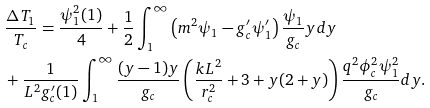Convert formula to latex. <formula><loc_0><loc_0><loc_500><loc_500>& \frac { \Delta T _ { 1 } } { T _ { c } } = \frac { \psi _ { 1 } ^ { 2 } ( 1 ) } { 4 } + \frac { 1 } { 2 } \int ^ { \infty } _ { 1 } \left ( m ^ { 2 } \psi _ { 1 } - g _ { c } ^ { \prime } \psi _ { 1 } ^ { \prime } \right ) \frac { \psi _ { 1 } } { g _ { c } } y d y \\ & + \frac { 1 } { L ^ { 2 } g _ { c } ^ { \prime } ( 1 ) } \int ^ { \infty } _ { 1 } \frac { ( y - 1 ) y } { g _ { c } } \left ( \frac { k L ^ { 2 } } { r _ { c } ^ { 2 } } + 3 + y ( 2 + y ) \right ) \frac { q ^ { 2 } \phi _ { c } ^ { 2 } \psi _ { 1 } ^ { 2 } } { g _ { c } } d y .</formula> 